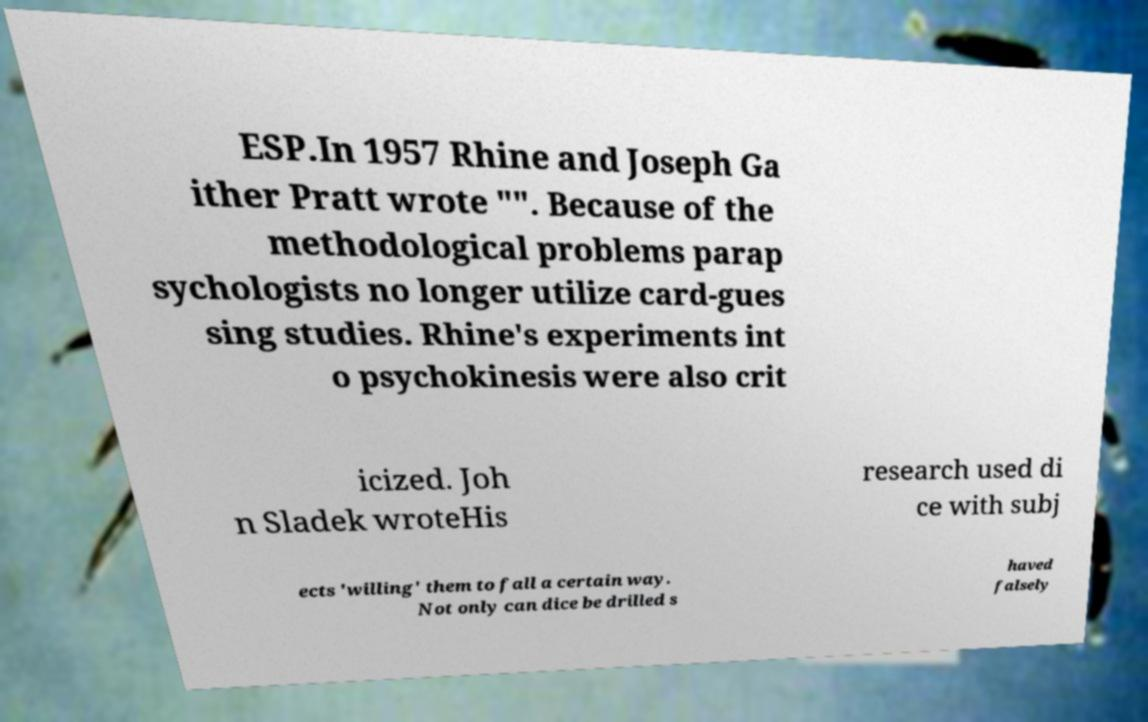What messages or text are displayed in this image? I need them in a readable, typed format. ESP.In 1957 Rhine and Joseph Ga ither Pratt wrote "". Because of the methodological problems parap sychologists no longer utilize card-gues sing studies. Rhine's experiments int o psychokinesis were also crit icized. Joh n Sladek wroteHis research used di ce with subj ects 'willing' them to fall a certain way. Not only can dice be drilled s haved falsely 